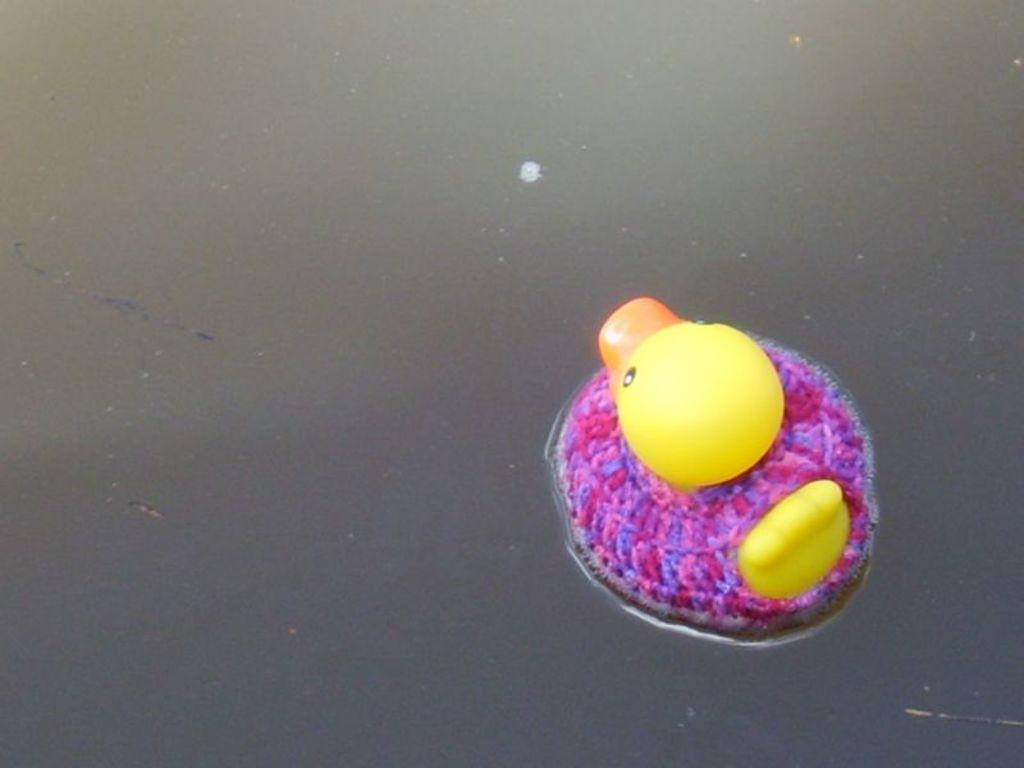What type of doll is in the image? There is a duck doll in the image. Where is the duck doll located? The duck doll is in a water body. What type of stove can be seen in the image? There is no stove present in the image; it features a duck doll in a water body. What animals can be seen at the zoo in the image? There is no zoo present in the image, as it only shows a duck doll in a water body. 